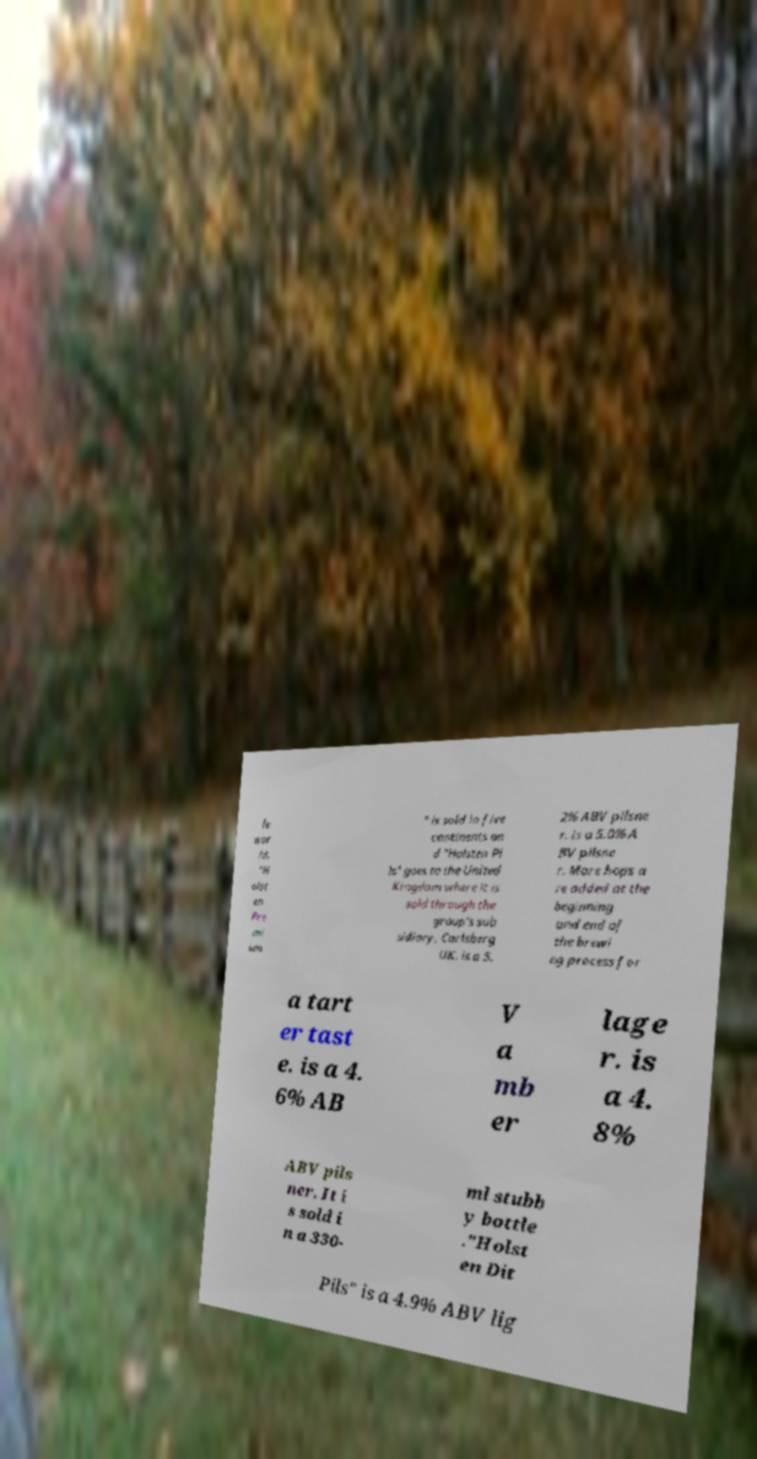Can you accurately transcribe the text from the provided image for me? le wor ld. "H olst en Pre mi um " is sold in five continents an d "Holsten Pi ls" goes to the United Kingdom where it is sold through the group's sub sidiary, Carlsberg UK. is a 5. 2% ABV pilsne r. is a 5.0% A BV pilsne r. More hops a re added at the beginning and end of the brewi ng process for a tart er tast e. is a 4. 6% AB V a mb er lage r. is a 4. 8% ABV pils ner. It i s sold i n a 330- ml stubb y bottle ."Holst en Dit Pils" is a 4.9% ABV lig 